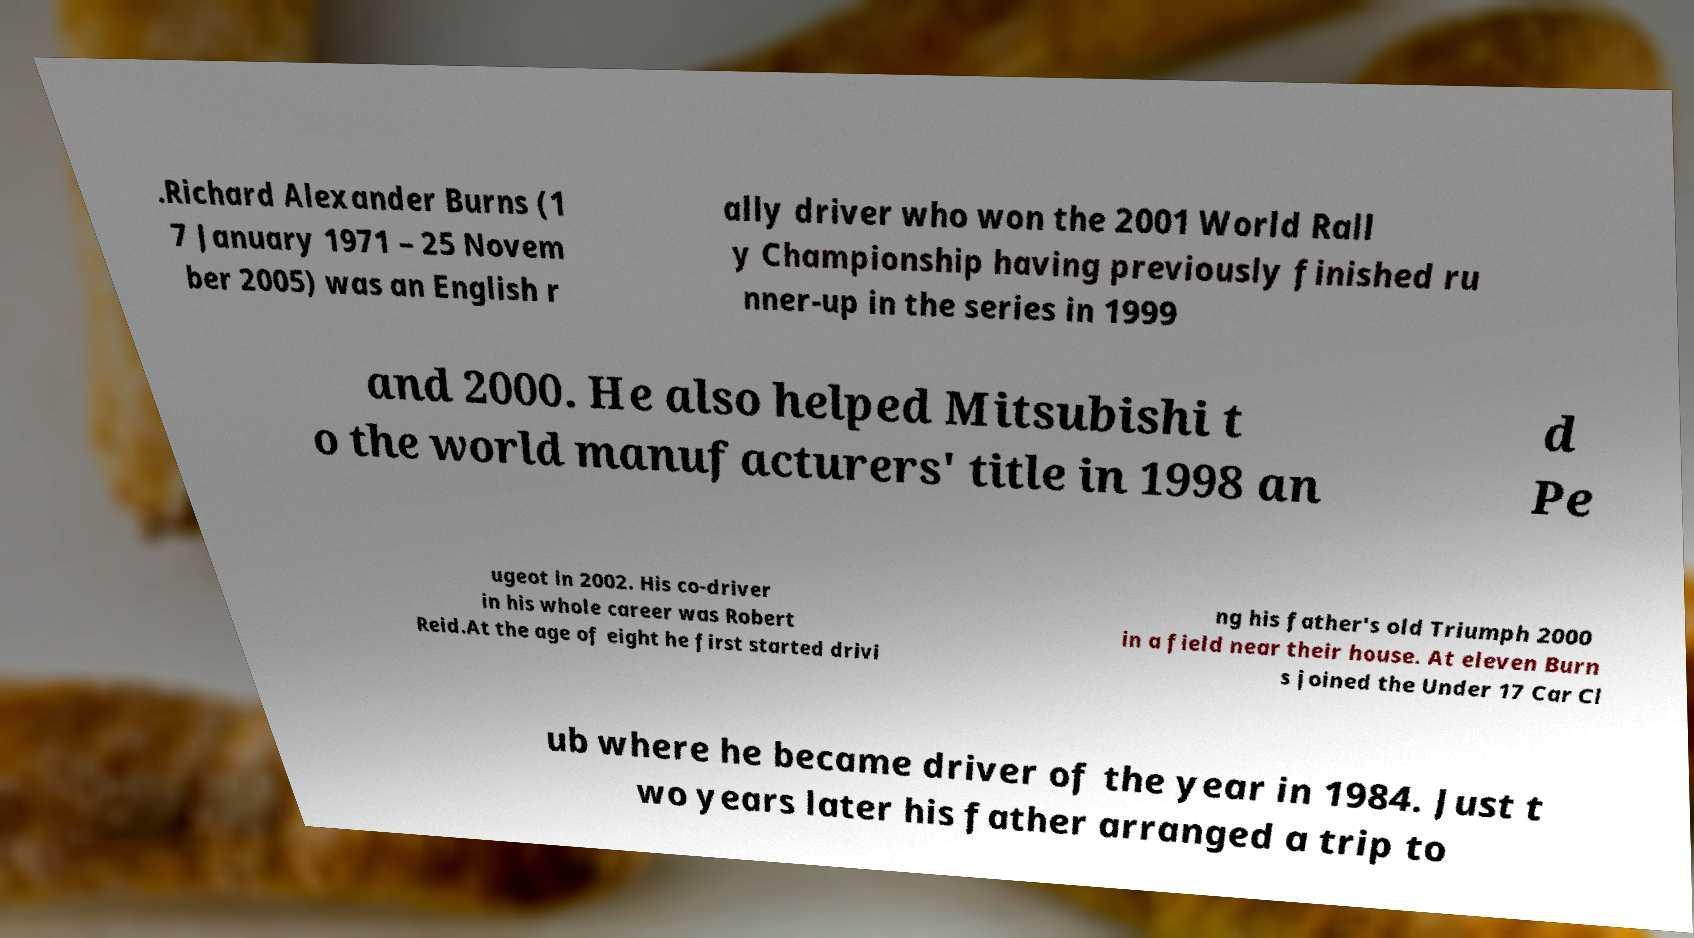Could you extract and type out the text from this image? .Richard Alexander Burns (1 7 January 1971 – 25 Novem ber 2005) was an English r ally driver who won the 2001 World Rall y Championship having previously finished ru nner-up in the series in 1999 and 2000. He also helped Mitsubishi t o the world manufacturers' title in 1998 an d Pe ugeot in 2002. His co-driver in his whole career was Robert Reid.At the age of eight he first started drivi ng his father's old Triumph 2000 in a field near their house. At eleven Burn s joined the Under 17 Car Cl ub where he became driver of the year in 1984. Just t wo years later his father arranged a trip to 